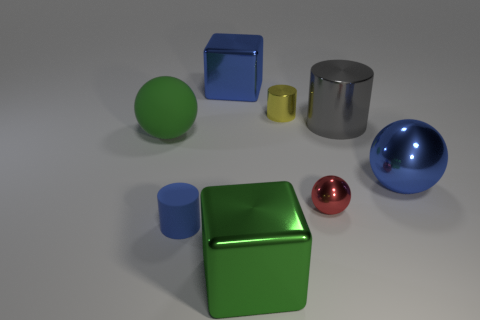Are there any gray objects to the right of the metallic cylinder behind the big gray cylinder?
Keep it short and to the point. Yes. There is a big object that is both on the left side of the big green shiny thing and in front of the large blue block; what is its color?
Your response must be concise. Green. Are there any red objects behind the large metallic object that is in front of the cylinder that is on the left side of the tiny yellow object?
Ensure brevity in your answer.  Yes. What is the size of the yellow object that is the same shape as the tiny blue object?
Offer a terse response. Small. Is there a tiny brown block?
Ensure brevity in your answer.  No. Do the big metallic ball and the cylinder that is to the left of the small metallic cylinder have the same color?
Ensure brevity in your answer.  Yes. What size is the cylinder that is in front of the big ball that is on the right side of the big green object that is to the right of the green matte thing?
Your response must be concise. Small. How many large cylinders are the same color as the big shiny ball?
Make the answer very short. 0. What number of objects are either red objects or blue objects that are in front of the yellow object?
Keep it short and to the point. 3. The matte cylinder is what color?
Offer a terse response. Blue. 